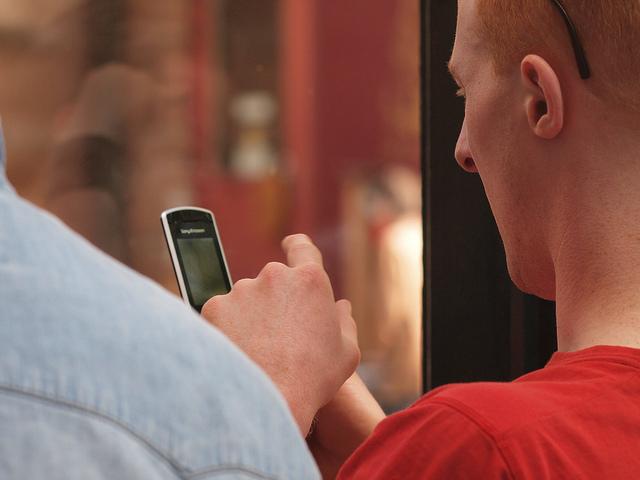What is the woman holding?
Concise answer only. Phone. Does the man in red have glasses on his head?
Concise answer only. Yes. With what hand is he holding the phone?
Give a very brief answer. Right. 